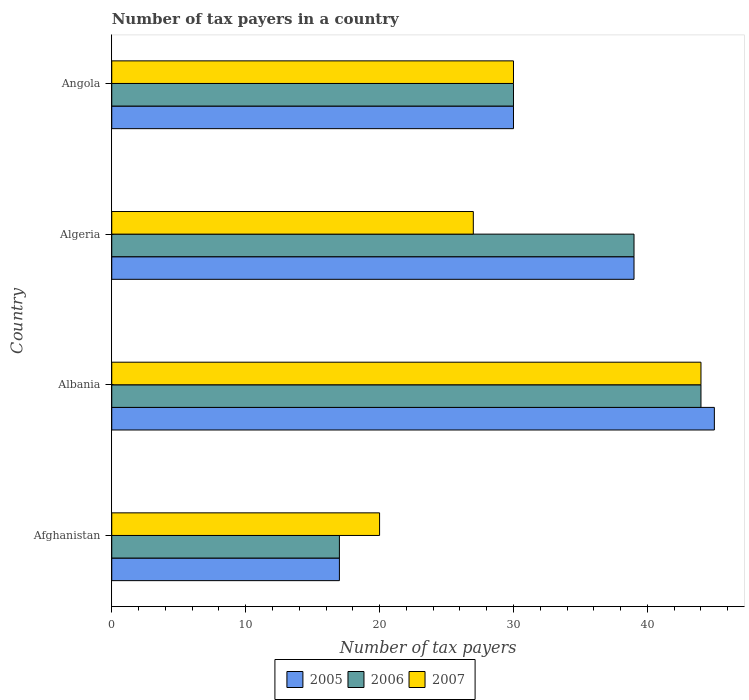How many groups of bars are there?
Keep it short and to the point. 4. How many bars are there on the 1st tick from the top?
Provide a short and direct response. 3. How many bars are there on the 1st tick from the bottom?
Your response must be concise. 3. What is the label of the 2nd group of bars from the top?
Provide a short and direct response. Algeria. In how many cases, is the number of bars for a given country not equal to the number of legend labels?
Give a very brief answer. 0. What is the number of tax payers in in 2006 in Albania?
Offer a terse response. 44. Across all countries, what is the minimum number of tax payers in in 2005?
Give a very brief answer. 17. In which country was the number of tax payers in in 2007 maximum?
Provide a short and direct response. Albania. In which country was the number of tax payers in in 2006 minimum?
Keep it short and to the point. Afghanistan. What is the total number of tax payers in in 2006 in the graph?
Your response must be concise. 130. What is the difference between the number of tax payers in in 2005 in Albania and the number of tax payers in in 2006 in Angola?
Offer a terse response. 15. What is the average number of tax payers in in 2006 per country?
Make the answer very short. 32.5. What is the ratio of the number of tax payers in in 2006 in Afghanistan to that in Albania?
Provide a short and direct response. 0.39. Is the number of tax payers in in 2006 in Albania less than that in Angola?
Your answer should be very brief. No. Is the difference between the number of tax payers in in 2005 in Afghanistan and Algeria greater than the difference between the number of tax payers in in 2006 in Afghanistan and Algeria?
Your response must be concise. No. What is the difference between the highest and the lowest number of tax payers in in 2005?
Provide a short and direct response. 28. In how many countries, is the number of tax payers in in 2006 greater than the average number of tax payers in in 2006 taken over all countries?
Ensure brevity in your answer.  2. Is the sum of the number of tax payers in in 2005 in Afghanistan and Albania greater than the maximum number of tax payers in in 2006 across all countries?
Your response must be concise. Yes. What does the 1st bar from the top in Afghanistan represents?
Offer a terse response. 2007. How many countries are there in the graph?
Provide a short and direct response. 4. What is the difference between two consecutive major ticks on the X-axis?
Offer a terse response. 10. Are the values on the major ticks of X-axis written in scientific E-notation?
Give a very brief answer. No. Does the graph contain grids?
Provide a short and direct response. No. What is the title of the graph?
Keep it short and to the point. Number of tax payers in a country. What is the label or title of the X-axis?
Make the answer very short. Number of tax payers. What is the Number of tax payers in 2007 in Albania?
Your answer should be compact. 44. What is the Number of tax payers of 2005 in Algeria?
Provide a succinct answer. 39. What is the Number of tax payers in 2005 in Angola?
Ensure brevity in your answer.  30. What is the Number of tax payers in 2007 in Angola?
Provide a succinct answer. 30. Across all countries, what is the maximum Number of tax payers in 2005?
Provide a succinct answer. 45. Across all countries, what is the maximum Number of tax payers of 2006?
Your response must be concise. 44. What is the total Number of tax payers of 2005 in the graph?
Your response must be concise. 131. What is the total Number of tax payers in 2006 in the graph?
Give a very brief answer. 130. What is the total Number of tax payers of 2007 in the graph?
Give a very brief answer. 121. What is the difference between the Number of tax payers of 2005 in Afghanistan and that in Albania?
Provide a short and direct response. -28. What is the difference between the Number of tax payers in 2006 in Afghanistan and that in Albania?
Your answer should be very brief. -27. What is the difference between the Number of tax payers of 2007 in Afghanistan and that in Albania?
Your answer should be compact. -24. What is the difference between the Number of tax payers in 2006 in Afghanistan and that in Algeria?
Provide a succinct answer. -22. What is the difference between the Number of tax payers in 2007 in Afghanistan and that in Angola?
Provide a short and direct response. -10. What is the difference between the Number of tax payers of 2006 in Albania and that in Angola?
Your answer should be compact. 14. What is the difference between the Number of tax payers of 2007 in Albania and that in Angola?
Your answer should be compact. 14. What is the difference between the Number of tax payers of 2005 in Algeria and that in Angola?
Give a very brief answer. 9. What is the difference between the Number of tax payers in 2006 in Algeria and that in Angola?
Your answer should be very brief. 9. What is the difference between the Number of tax payers of 2005 in Afghanistan and the Number of tax payers of 2006 in Albania?
Give a very brief answer. -27. What is the difference between the Number of tax payers in 2005 in Afghanistan and the Number of tax payers in 2007 in Algeria?
Your answer should be compact. -10. What is the difference between the Number of tax payers in 2005 in Afghanistan and the Number of tax payers in 2006 in Angola?
Provide a short and direct response. -13. What is the difference between the Number of tax payers in 2006 in Afghanistan and the Number of tax payers in 2007 in Angola?
Make the answer very short. -13. What is the difference between the Number of tax payers of 2005 in Albania and the Number of tax payers of 2006 in Angola?
Provide a succinct answer. 15. What is the difference between the Number of tax payers in 2005 in Albania and the Number of tax payers in 2007 in Angola?
Make the answer very short. 15. What is the difference between the Number of tax payers of 2006 in Albania and the Number of tax payers of 2007 in Angola?
Provide a short and direct response. 14. What is the difference between the Number of tax payers in 2005 in Algeria and the Number of tax payers in 2006 in Angola?
Ensure brevity in your answer.  9. What is the difference between the Number of tax payers of 2006 in Algeria and the Number of tax payers of 2007 in Angola?
Give a very brief answer. 9. What is the average Number of tax payers in 2005 per country?
Keep it short and to the point. 32.75. What is the average Number of tax payers in 2006 per country?
Your answer should be very brief. 32.5. What is the average Number of tax payers of 2007 per country?
Provide a short and direct response. 30.25. What is the difference between the Number of tax payers of 2005 and Number of tax payers of 2006 in Afghanistan?
Your answer should be compact. 0. What is the difference between the Number of tax payers in 2005 and Number of tax payers in 2006 in Albania?
Give a very brief answer. 1. What is the difference between the Number of tax payers in 2005 and Number of tax payers in 2007 in Albania?
Make the answer very short. 1. What is the difference between the Number of tax payers of 2005 and Number of tax payers of 2006 in Algeria?
Offer a terse response. 0. What is the difference between the Number of tax payers of 2005 and Number of tax payers of 2007 in Algeria?
Your answer should be compact. 12. What is the difference between the Number of tax payers of 2005 and Number of tax payers of 2006 in Angola?
Your answer should be very brief. 0. What is the difference between the Number of tax payers of 2006 and Number of tax payers of 2007 in Angola?
Your answer should be compact. 0. What is the ratio of the Number of tax payers in 2005 in Afghanistan to that in Albania?
Make the answer very short. 0.38. What is the ratio of the Number of tax payers in 2006 in Afghanistan to that in Albania?
Make the answer very short. 0.39. What is the ratio of the Number of tax payers of 2007 in Afghanistan to that in Albania?
Offer a very short reply. 0.45. What is the ratio of the Number of tax payers of 2005 in Afghanistan to that in Algeria?
Provide a short and direct response. 0.44. What is the ratio of the Number of tax payers in 2006 in Afghanistan to that in Algeria?
Offer a terse response. 0.44. What is the ratio of the Number of tax payers in 2007 in Afghanistan to that in Algeria?
Make the answer very short. 0.74. What is the ratio of the Number of tax payers of 2005 in Afghanistan to that in Angola?
Offer a terse response. 0.57. What is the ratio of the Number of tax payers in 2006 in Afghanistan to that in Angola?
Give a very brief answer. 0.57. What is the ratio of the Number of tax payers of 2007 in Afghanistan to that in Angola?
Offer a very short reply. 0.67. What is the ratio of the Number of tax payers of 2005 in Albania to that in Algeria?
Ensure brevity in your answer.  1.15. What is the ratio of the Number of tax payers of 2006 in Albania to that in Algeria?
Ensure brevity in your answer.  1.13. What is the ratio of the Number of tax payers in 2007 in Albania to that in Algeria?
Offer a terse response. 1.63. What is the ratio of the Number of tax payers of 2005 in Albania to that in Angola?
Keep it short and to the point. 1.5. What is the ratio of the Number of tax payers in 2006 in Albania to that in Angola?
Offer a very short reply. 1.47. What is the ratio of the Number of tax payers of 2007 in Albania to that in Angola?
Make the answer very short. 1.47. What is the ratio of the Number of tax payers of 2007 in Algeria to that in Angola?
Offer a terse response. 0.9. What is the difference between the highest and the second highest Number of tax payers in 2007?
Provide a short and direct response. 14. 